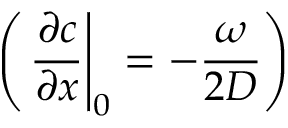Convert formula to latex. <formula><loc_0><loc_0><loc_500><loc_500>\left ( \frac { \partial c } { \partial x } \right | _ { 0 } = - \frac { \omega } { 2 D } \right )</formula> 